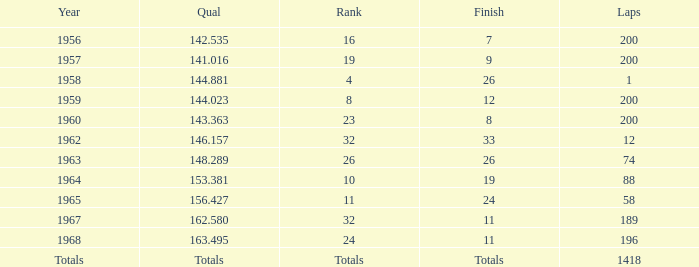What is the greatest quantity of laps that also results in a total of 8? 200.0. 